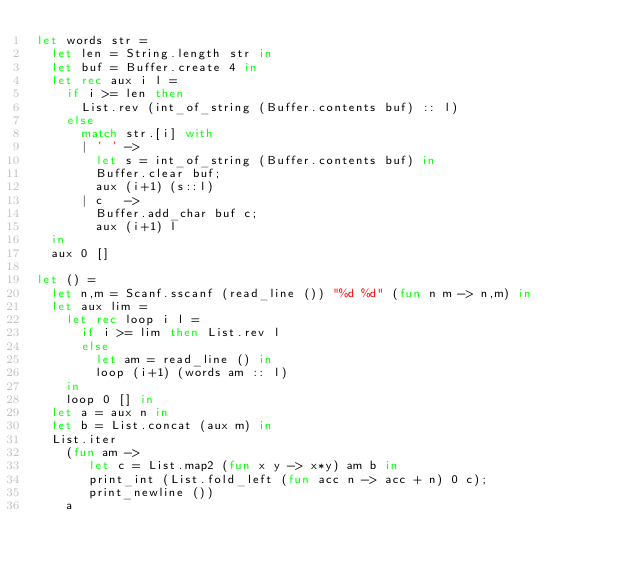Convert code to text. <code><loc_0><loc_0><loc_500><loc_500><_OCaml_>let words str =
  let len = String.length str in
  let buf = Buffer.create 4 in
  let rec aux i l =
    if i >= len then
      List.rev (int_of_string (Buffer.contents buf) :: l)
    else 
      match str.[i] with
      | ' ' ->
        let s = int_of_string (Buffer.contents buf) in
        Buffer.clear buf;
        aux (i+1) (s::l)
      | c   ->
        Buffer.add_char buf c;
        aux (i+1) l
  in
  aux 0 []

let () =
  let n,m = Scanf.sscanf (read_line ()) "%d %d" (fun n m -> n,m) in
  let aux lim =
    let rec loop i l =
      if i >= lim then List.rev l
      else
        let am = read_line () in
        loop (i+1) (words am :: l)
    in
    loop 0 [] in
  let a = aux n in
  let b = List.concat (aux m) in
  List.iter
    (fun am ->
       let c = List.map2 (fun x y -> x*y) am b in
       print_int (List.fold_left (fun acc n -> acc + n) 0 c);
       print_newline ())
    a</code> 